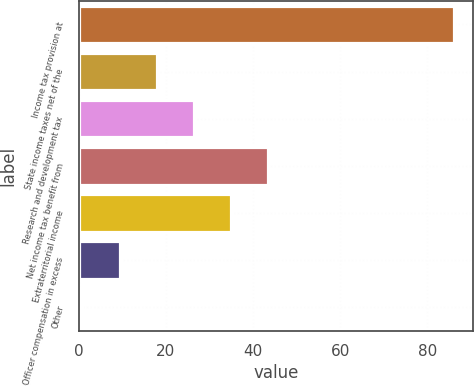<chart> <loc_0><loc_0><loc_500><loc_500><bar_chart><fcel>Income tax provision at<fcel>State income taxes net of the<fcel>Research and development tax<fcel>Net income tax benefit from<fcel>Extraterritorial income<fcel>Officer compensation in excess<fcel>Other<nl><fcel>86.2<fcel>17.96<fcel>26.49<fcel>43.55<fcel>35.02<fcel>9.43<fcel>0.9<nl></chart> 